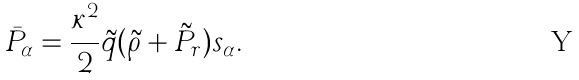<formula> <loc_0><loc_0><loc_500><loc_500>\bar { P } _ { \alpha } = \frac { \kappa ^ { 2 } } { 2 } \tilde { q } ( \tilde { \rho } + \tilde { P } _ { r } ) s _ { \alpha } .</formula> 